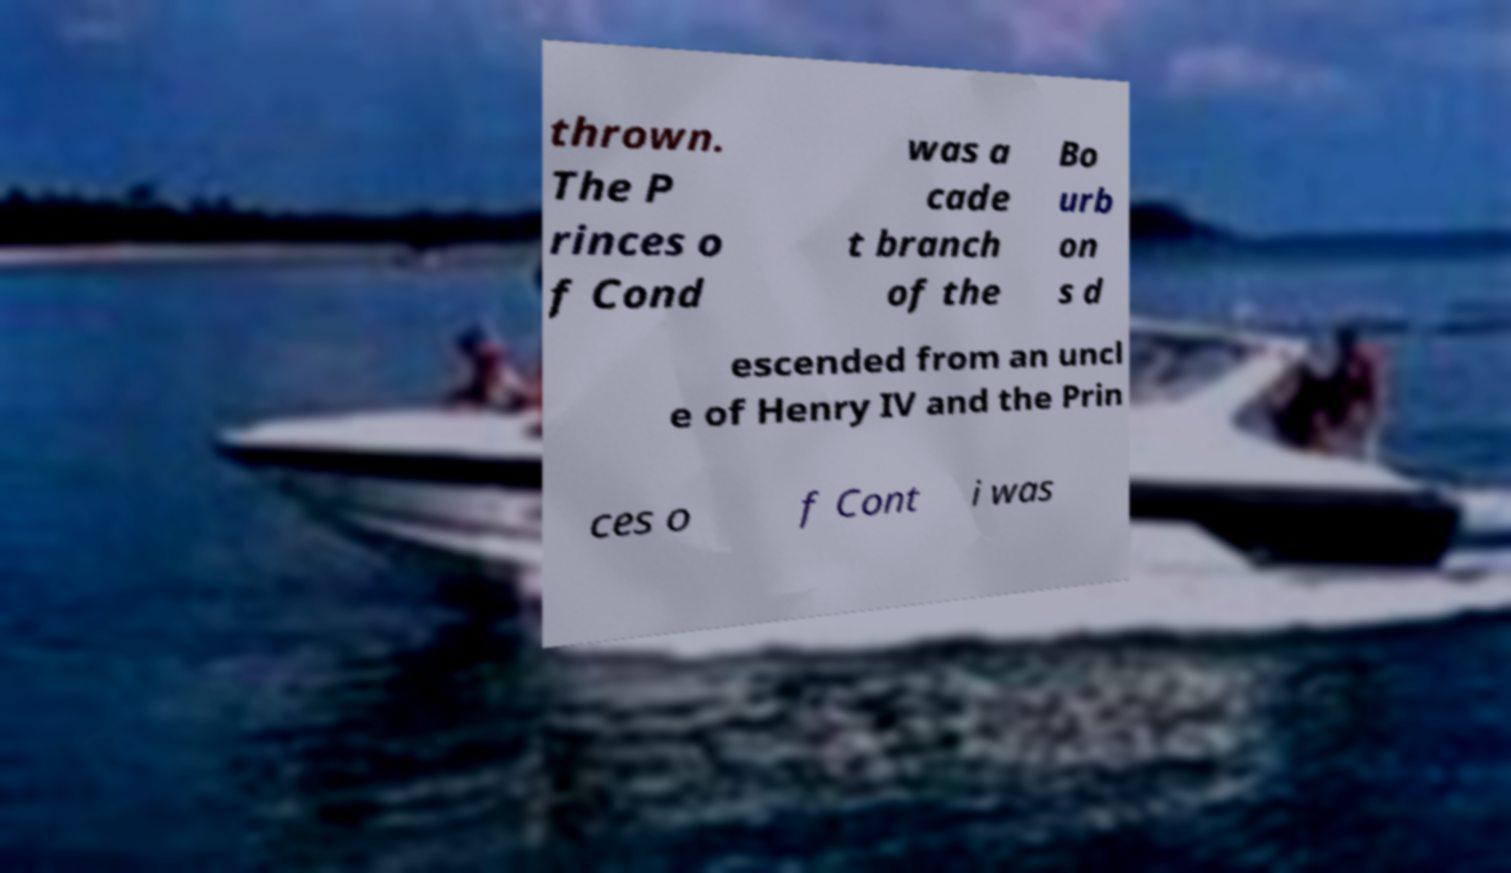Could you extract and type out the text from this image? thrown. The P rinces o f Cond was a cade t branch of the Bo urb on s d escended from an uncl e of Henry IV and the Prin ces o f Cont i was 